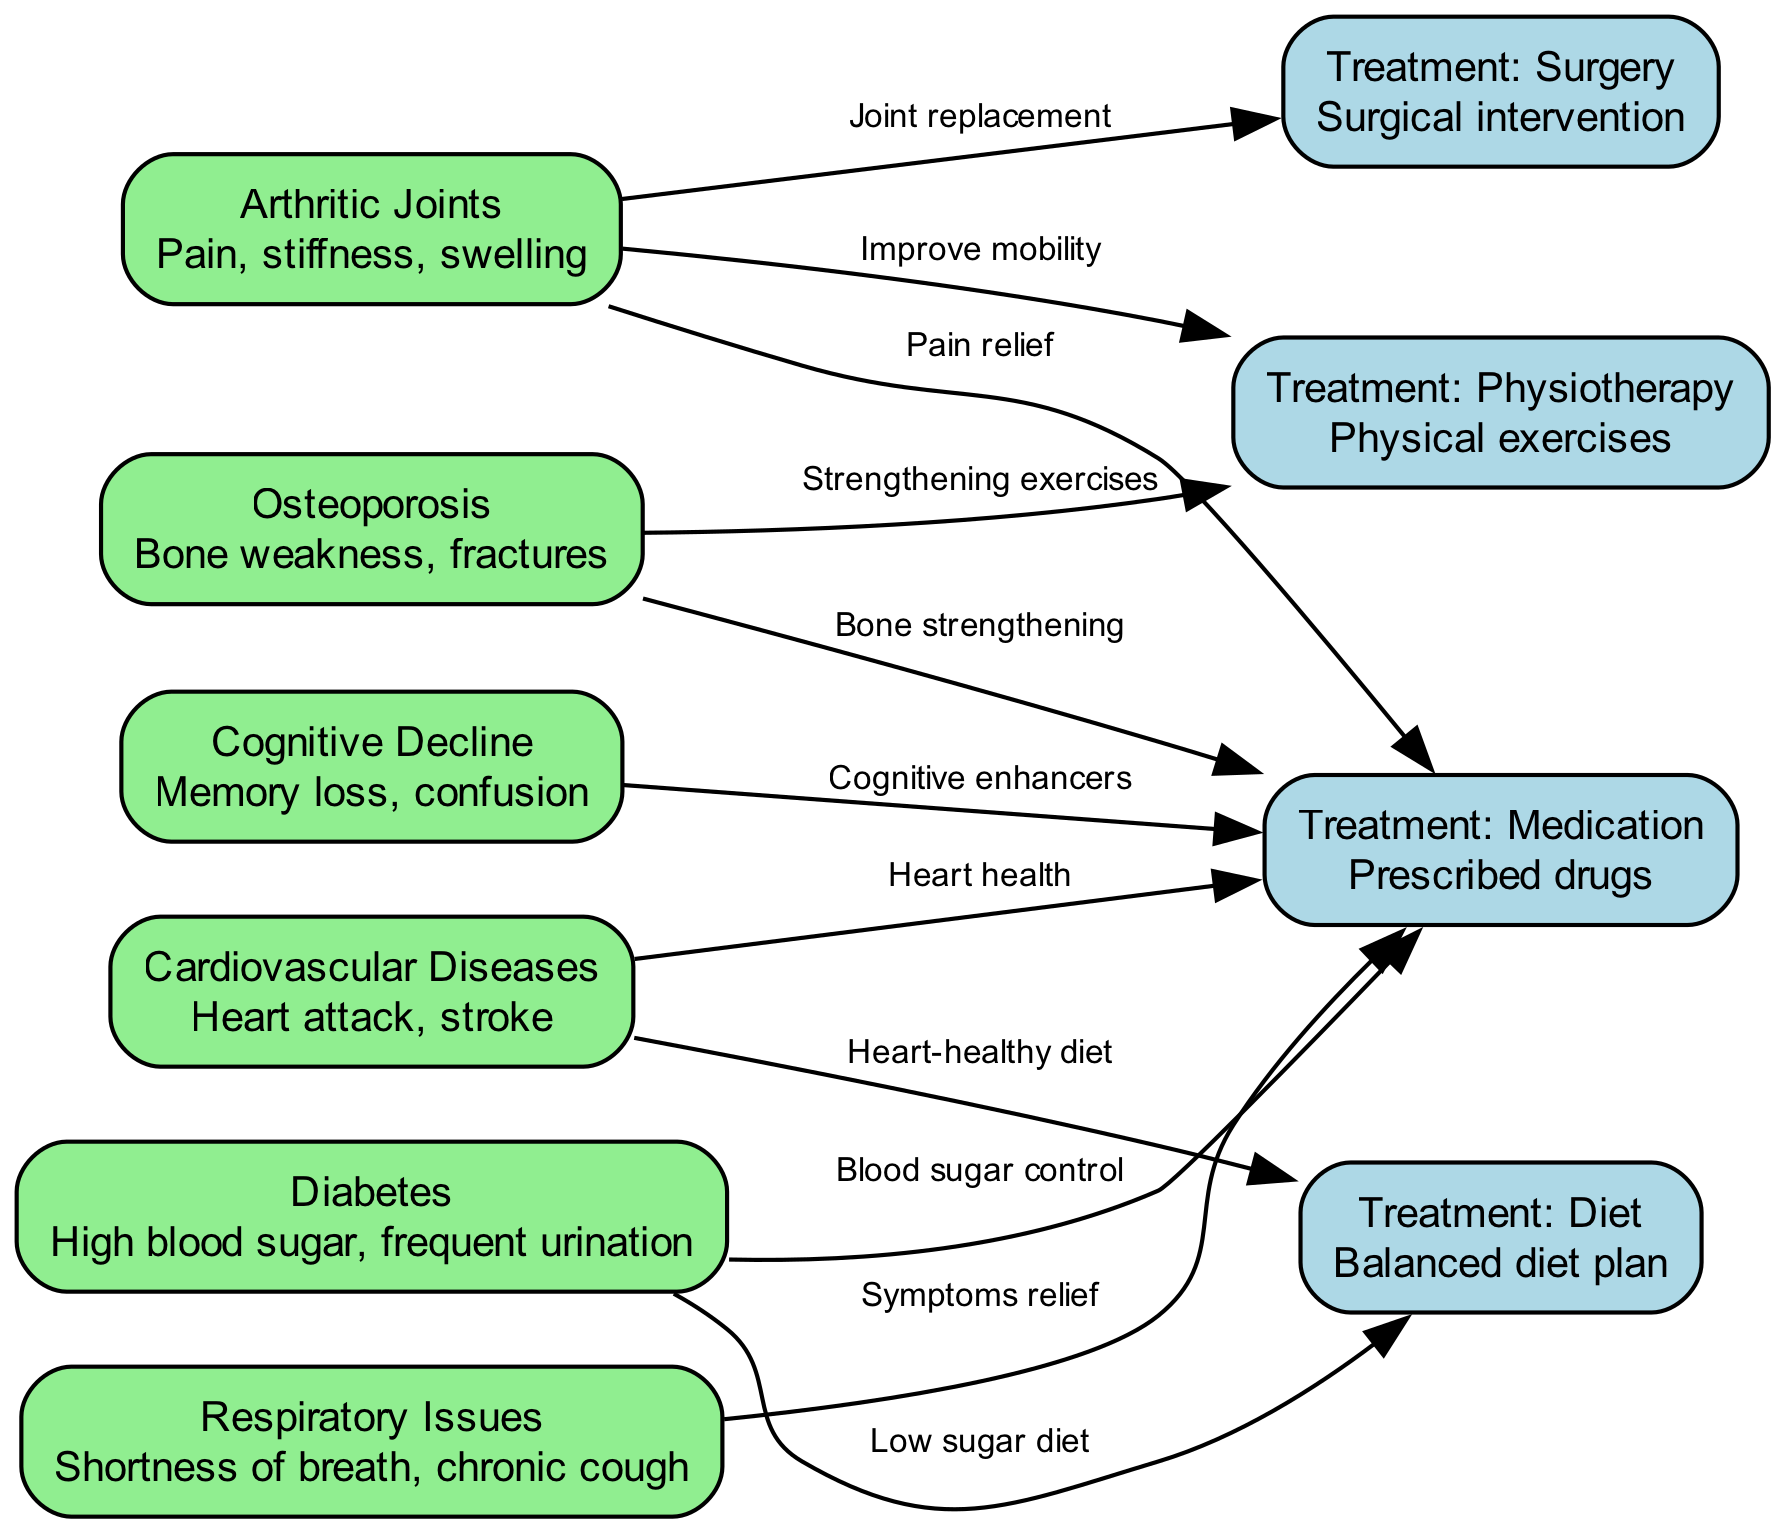What are the symptoms of cardiovascular diseases? The node labeled "Cardiovascular Diseases" details symptoms as "Heart attack, stroke," which can be found in the information linked with that node.
Answer: Heart attack, stroke How many treatment options are listed in the diagram? By counting the distinct treatment nodes: "Treatment: Medication," "Treatment: Physiotherapy," "Treatment: Diet," and "Treatment: Surgery," there are four treatment options shown in the diagram.
Answer: 4 Which condition is associated with joint replacement surgery? The node "Arthritic Joints" has a direct connection to "Treatment: Surgery" with the label "Joint replacement," indicating this relationship clearly in the diagram.
Answer: Arthritic Joints What is the primary focus of treatment for diabetes? The diagram links "Diabetes" to "Treatment: Medication" with the label "Blood sugar control," focusing on how diabetes is treated.
Answer: Blood sugar control Which treatment is recommended for improving mobility related to arthritic joints? The node "Arthritic Joints" connects to "Treatment: Physiotherapy" with the label "Improve mobility." This indicates that physiotherapy is specifically recommended for this purpose.
Answer: Improve mobility What condition is linked to high blood sugar and frequent urination? The node labeled "Diabetes" entails the details "High blood sugar, frequent urination," providing clear identification of this condition.
Answer: Diabetes Which treatment is common for both osteoporosis and arthritic joints? Both "Osteoporosis" and "Arthritic Joints" link to "Treatment: Medication," signifying that medication is a common treatment avenue for both conditions.
Answer: Treatment: Medication What diet is recommended for cardiovascular diseases? The edge from "Cardiovascular Diseases" to "Treatment: Diet" specifies the label "Heart-healthy diet," which indicates the type of diet recommended for this condition.
Answer: Heart-healthy diet What type of exercises are suggested for those with osteoporosis? The edge connecting "Osteoporosis" to "Treatment: Physiotherapy" has the label "Strengthening exercises," explicitly suggesting the kind of exercise recommended.
Answer: Strengthening exercises 